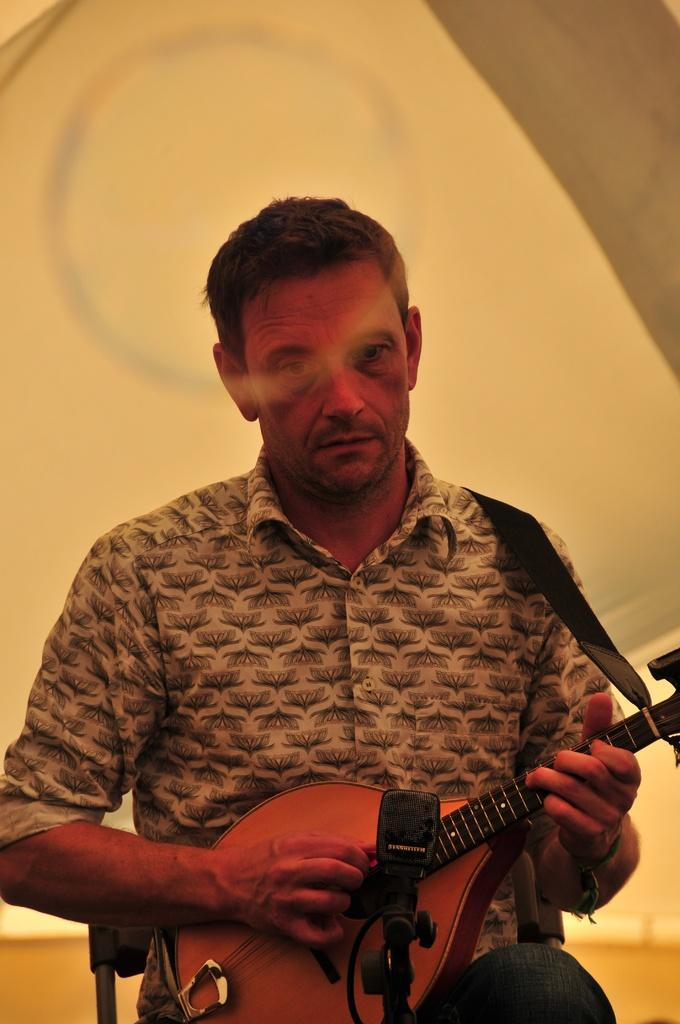What is the main subject of the picture? The main subject of the picture is a man. What is the man doing in the picture? The man is sitting and playing a musical instrument. How is the musical instrument positioned on the man? The musical instrument is worn around his shoulder. What is the man wearing in the picture? The man is wearing a flower design shirt. What color is the background of the image? The background of the image is cream-colored. What type of crack can be seen in the image? There is no crack present in the image. What word is written on the man's shirt in the image? The man's shirt has a flower design, but there are no words visible. 